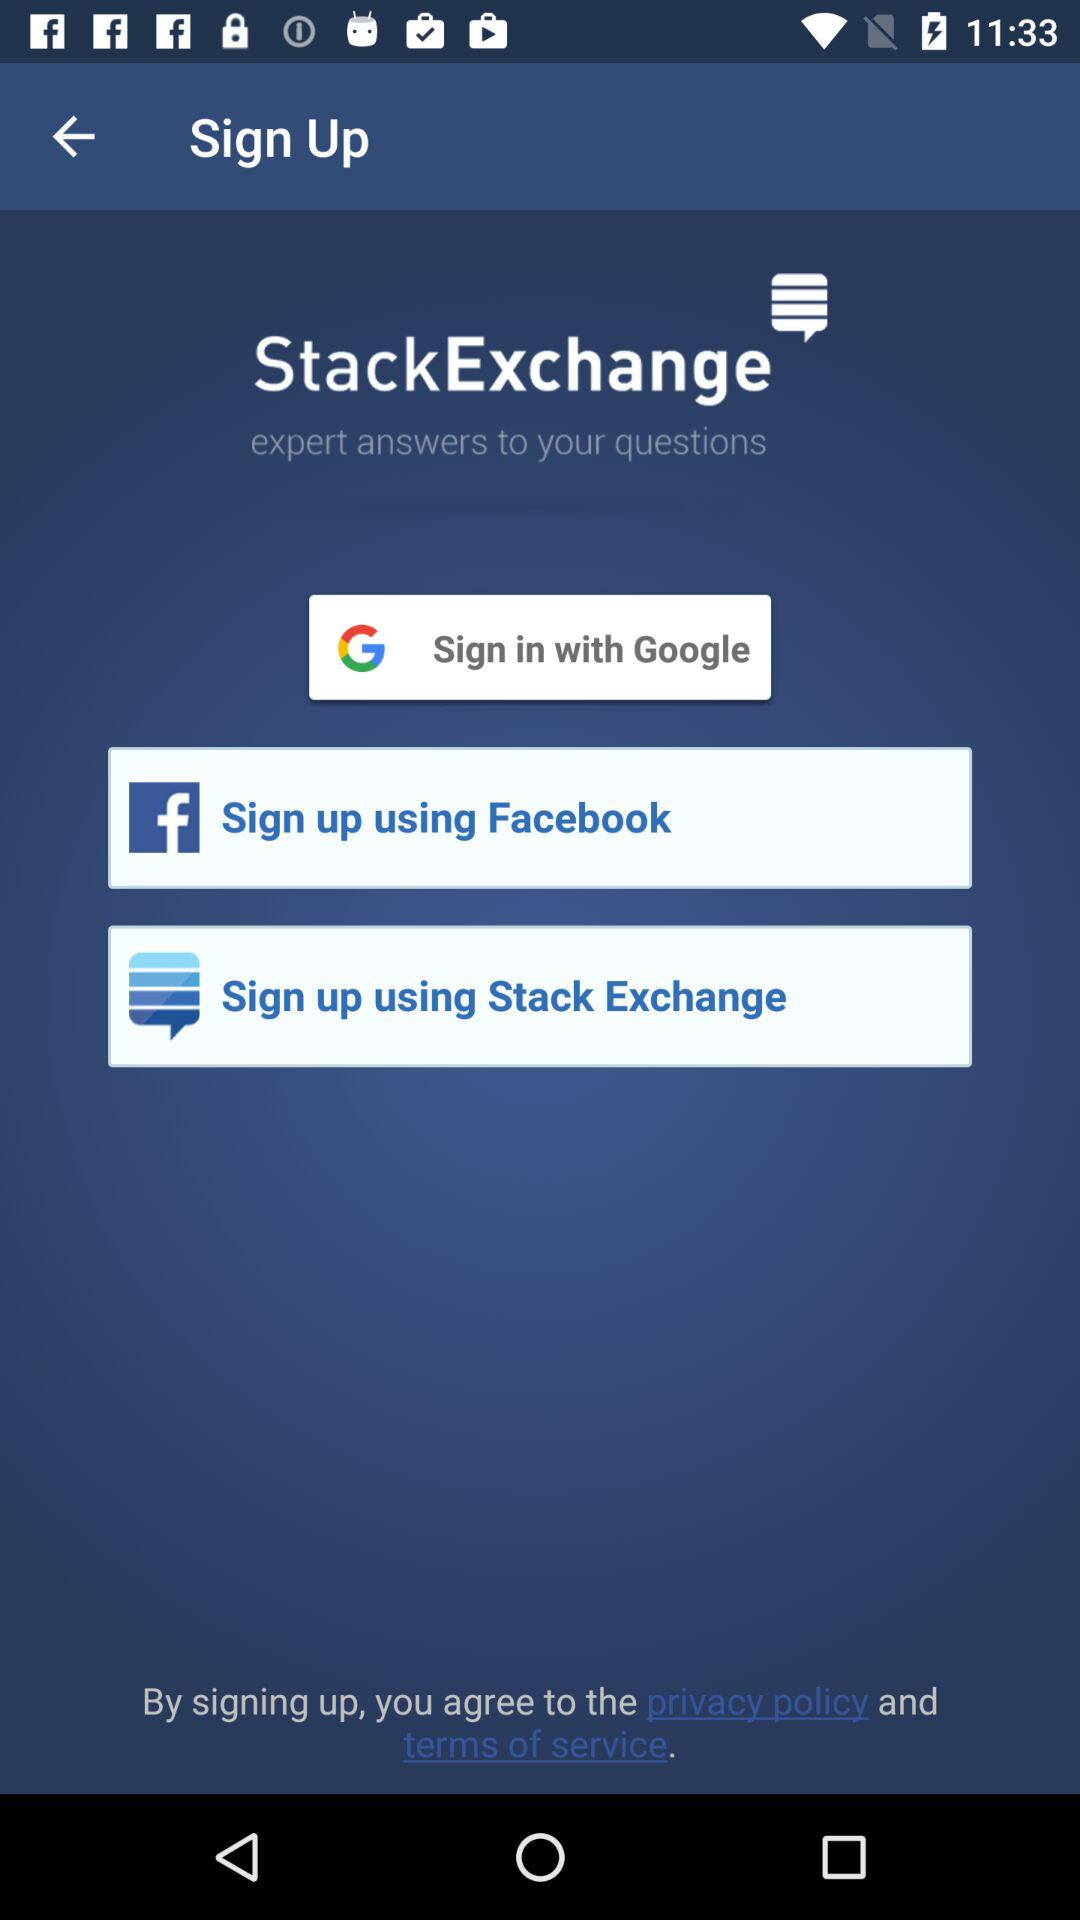What is the application name? The application name is "StackExchange". 